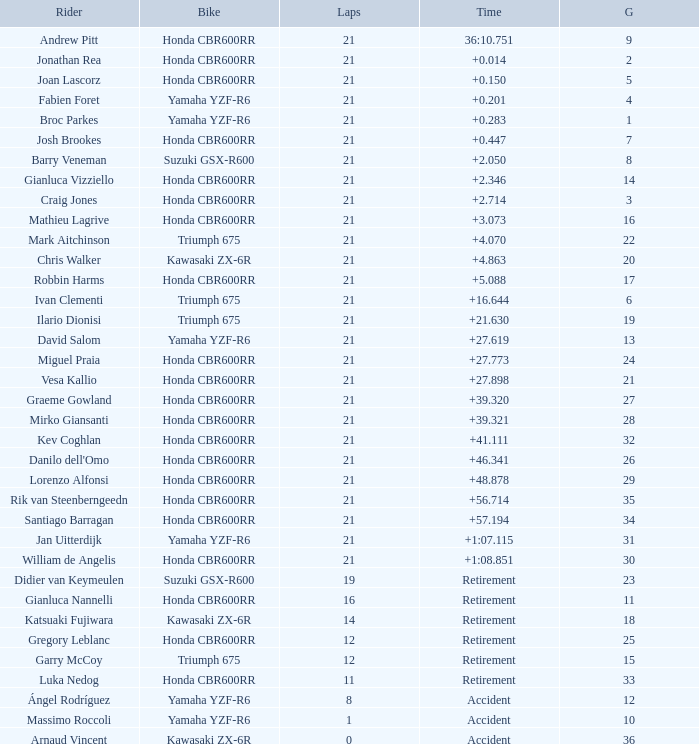What is the driver with the laps under 16, grid of 10, a bike of Yamaha YZF-R6, and ended with an accident? Massimo Roccoli. 